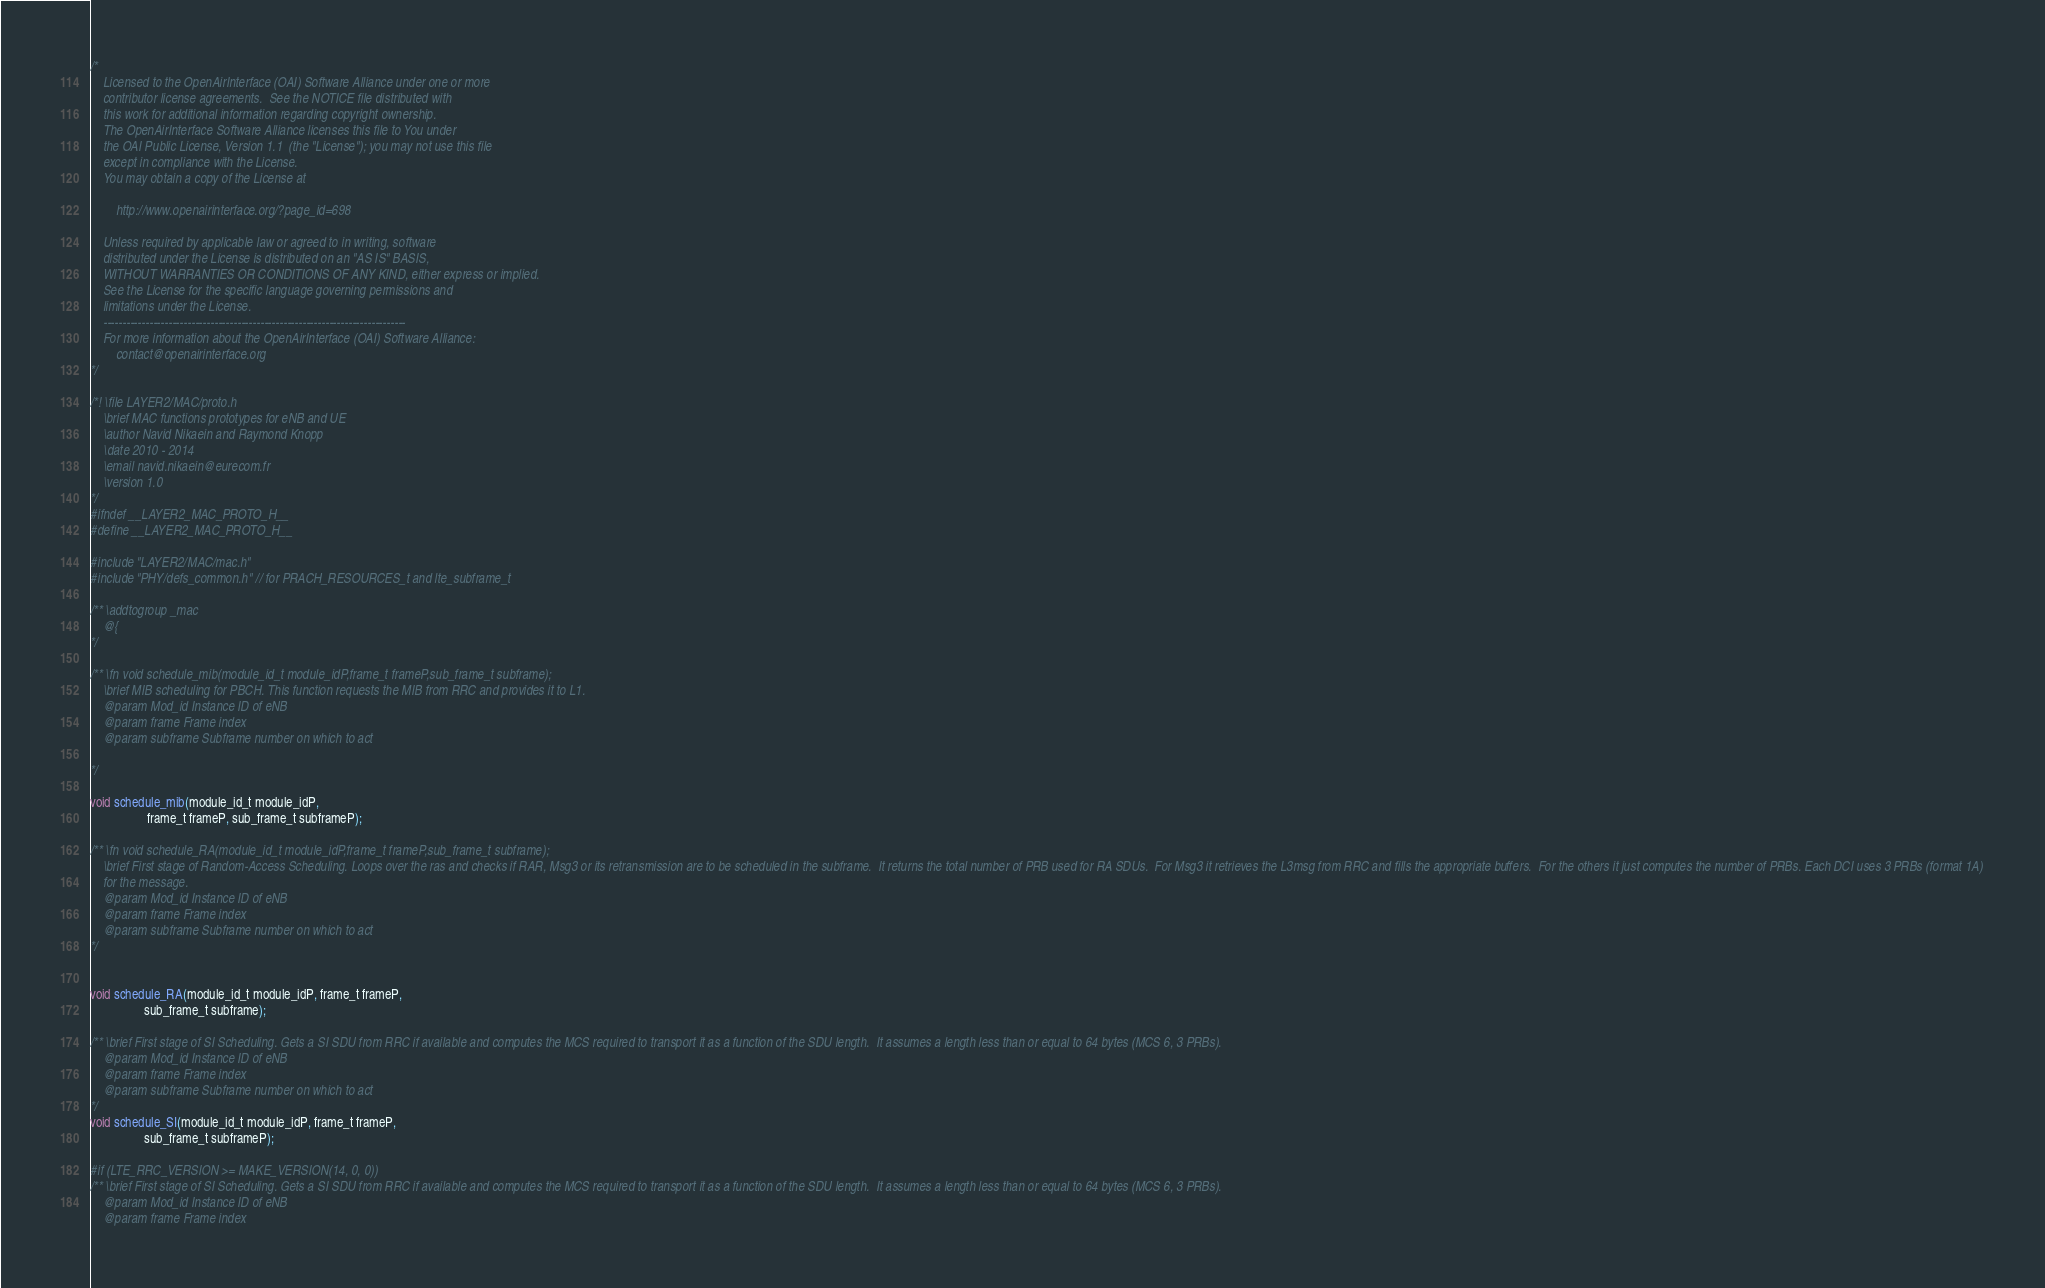Convert code to text. <code><loc_0><loc_0><loc_500><loc_500><_C_>/*
    Licensed to the OpenAirInterface (OAI) Software Alliance under one or more
    contributor license agreements.  See the NOTICE file distributed with
    this work for additional information regarding copyright ownership.
    The OpenAirInterface Software Alliance licenses this file to You under
    the OAI Public License, Version 1.1  (the "License"); you may not use this file
    except in compliance with the License.
    You may obtain a copy of the License at

        http://www.openairinterface.org/?page_id=698

    Unless required by applicable law or agreed to in writing, software
    distributed under the License is distributed on an "AS IS" BASIS,
    WITHOUT WARRANTIES OR CONDITIONS OF ANY KIND, either express or implied.
    See the License for the specific language governing permissions and
    limitations under the License.
    -------------------------------------------------------------------------------
    For more information about the OpenAirInterface (OAI) Software Alliance:
        contact@openairinterface.org
*/

/*! \file LAYER2/MAC/proto.h
    \brief MAC functions prototypes for eNB and UE
    \author Navid Nikaein and Raymond Knopp
    \date 2010 - 2014
    \email navid.nikaein@eurecom.fr
    \version 1.0
*/
#ifndef __LAYER2_MAC_PROTO_H__
#define __LAYER2_MAC_PROTO_H__

#include "LAYER2/MAC/mac.h"
#include "PHY/defs_common.h" // for PRACH_RESOURCES_t and lte_subframe_t

/** \addtogroup _mac
    @{
*/

/** \fn void schedule_mib(module_id_t module_idP,frame_t frameP,sub_frame_t subframe);
    \brief MIB scheduling for PBCH. This function requests the MIB from RRC and provides it to L1.
    @param Mod_id Instance ID of eNB
    @param frame Frame index
    @param subframe Subframe number on which to act

*/

void schedule_mib(module_id_t module_idP,
                  frame_t frameP, sub_frame_t subframeP);

/** \fn void schedule_RA(module_id_t module_idP,frame_t frameP,sub_frame_t subframe);
    \brief First stage of Random-Access Scheduling. Loops over the ras and checks if RAR, Msg3 or its retransmission are to be scheduled in the subframe.  It returns the total number of PRB used for RA SDUs.  For Msg3 it retrieves the L3msg from RRC and fills the appropriate buffers.  For the others it just computes the number of PRBs. Each DCI uses 3 PRBs (format 1A)
    for the message.
    @param Mod_id Instance ID of eNB
    @param frame Frame index
    @param subframe Subframe number on which to act
*/


void schedule_RA(module_id_t module_idP, frame_t frameP,
                 sub_frame_t subframe);

/** \brief First stage of SI Scheduling. Gets a SI SDU from RRC if available and computes the MCS required to transport it as a function of the SDU length.  It assumes a length less than or equal to 64 bytes (MCS 6, 3 PRBs).
    @param Mod_id Instance ID of eNB
    @param frame Frame index
    @param subframe Subframe number on which to act
*/
void schedule_SI(module_id_t module_idP, frame_t frameP,
                 sub_frame_t subframeP);

#if (LTE_RRC_VERSION >= MAKE_VERSION(14, 0, 0))
/** \brief First stage of SI Scheduling. Gets a SI SDU from RRC if available and computes the MCS required to transport it as a function of the SDU length.  It assumes a length less than or equal to 64 bytes (MCS 6, 3 PRBs).
    @param Mod_id Instance ID of eNB
    @param frame Frame index</code> 